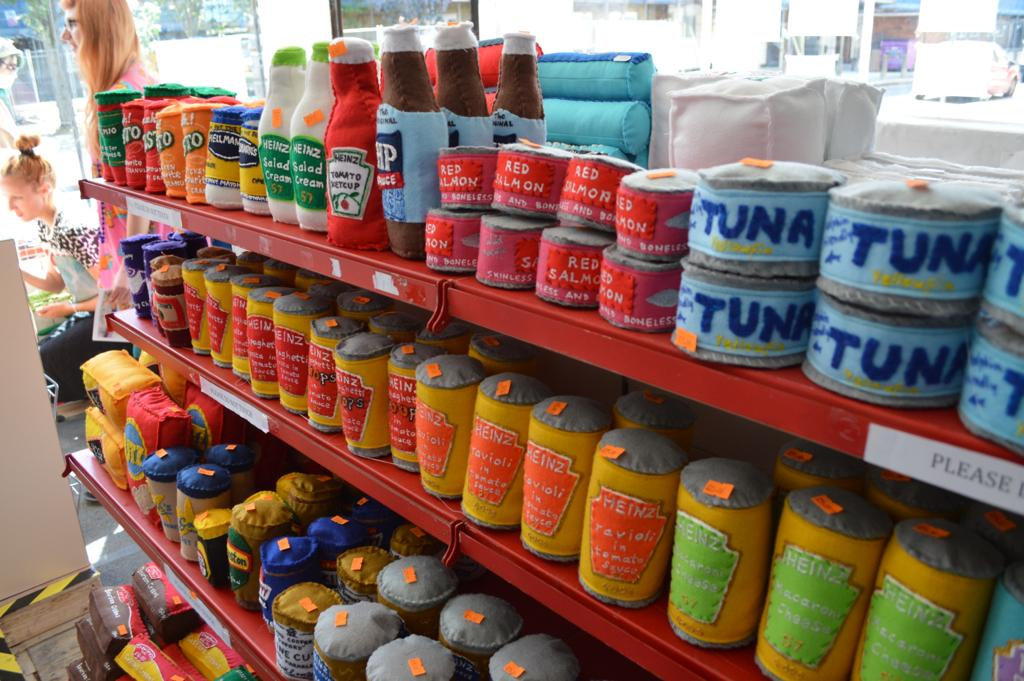<image>
Relay a brief, clear account of the picture shown. The blue cans on the top right are full of tuna 